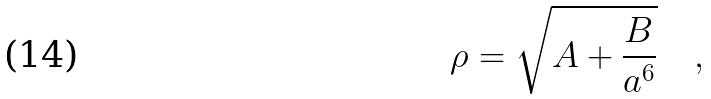Convert formula to latex. <formula><loc_0><loc_0><loc_500><loc_500>\rho = \sqrt { A + \frac { B } { a ^ { 6 } } } \quad ,</formula> 